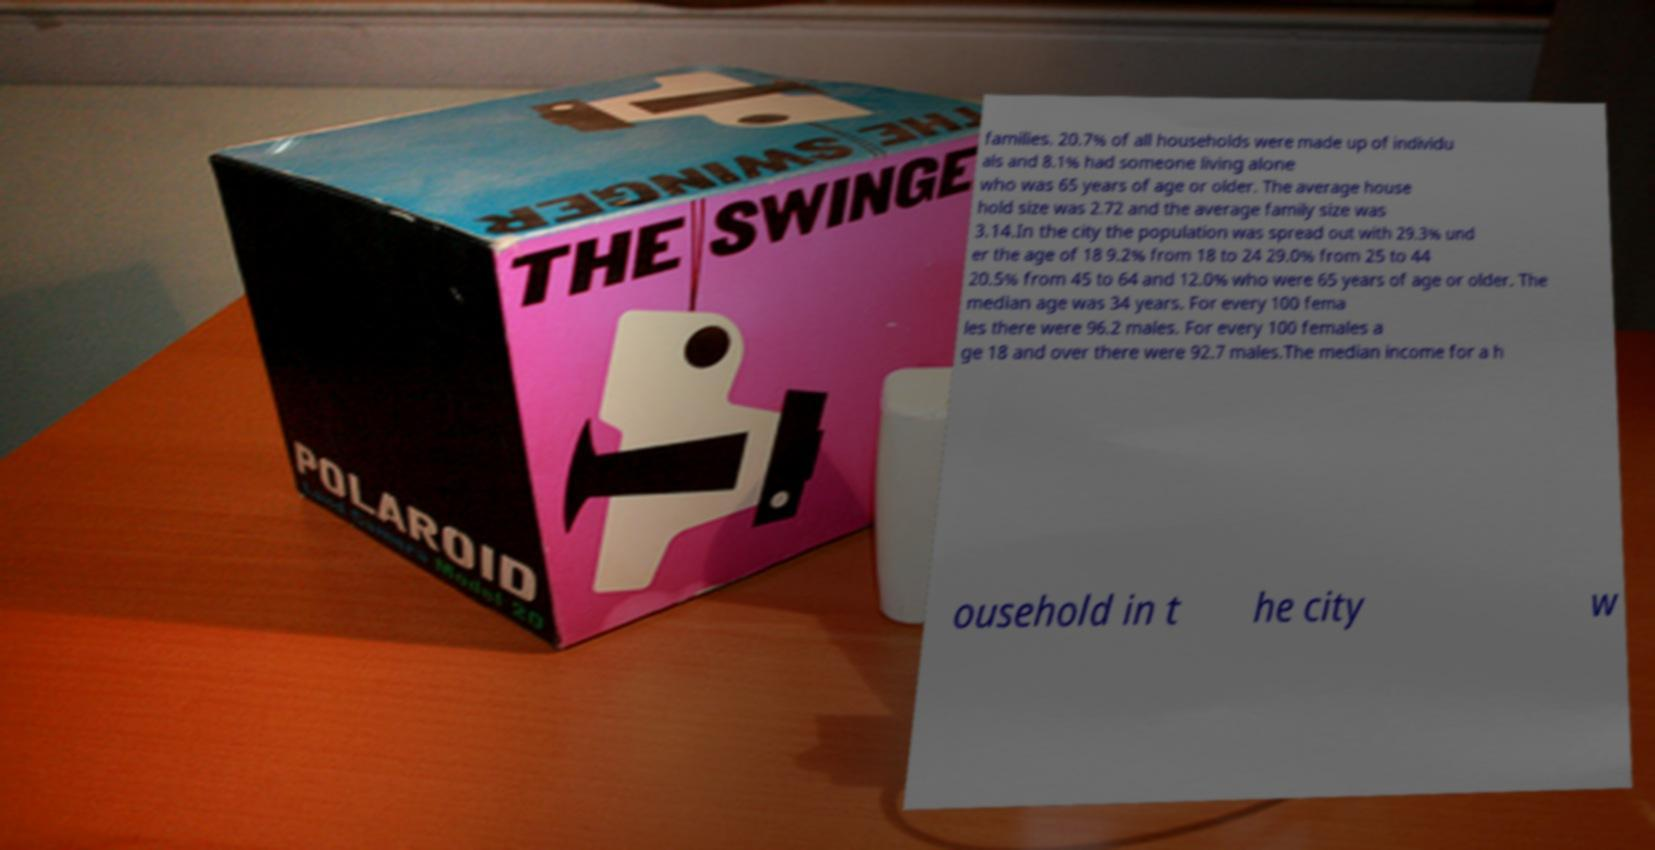Please read and relay the text visible in this image. What does it say? families. 20.7% of all households were made up of individu als and 8.1% had someone living alone who was 65 years of age or older. The average house hold size was 2.72 and the average family size was 3.14.In the city the population was spread out with 29.3% und er the age of 18 9.2% from 18 to 24 29.0% from 25 to 44 20.5% from 45 to 64 and 12.0% who were 65 years of age or older. The median age was 34 years. For every 100 fema les there were 96.2 males. For every 100 females a ge 18 and over there were 92.7 males.The median income for a h ousehold in t he city w 